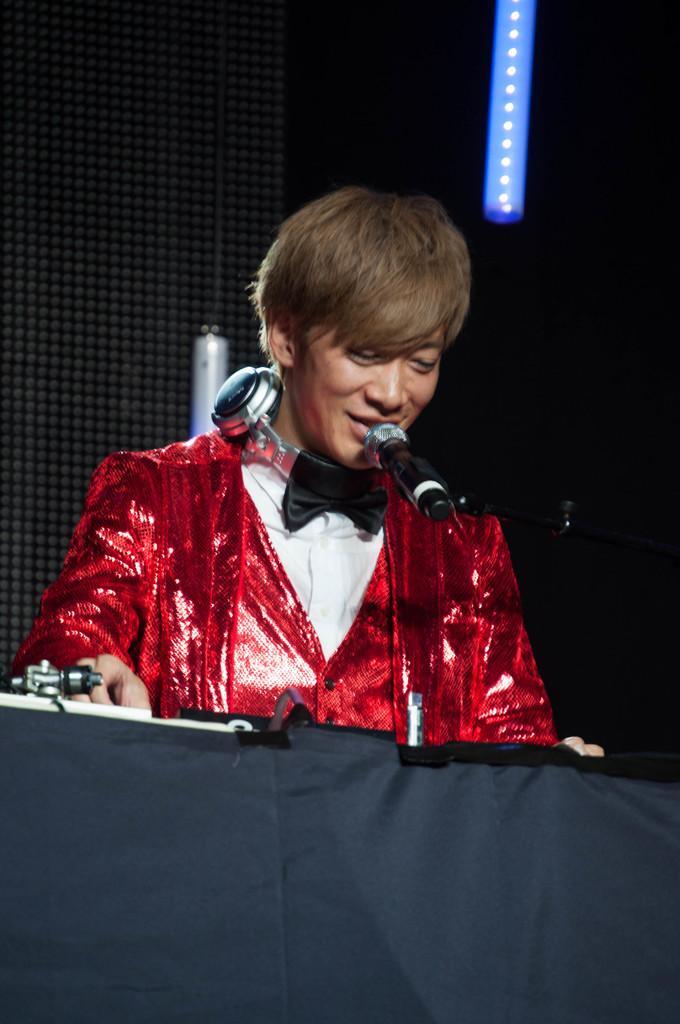In one or two sentences, can you explain what this image depicts? There is a man wore headset, in front of this man we can see microphone. Background we can see light. 